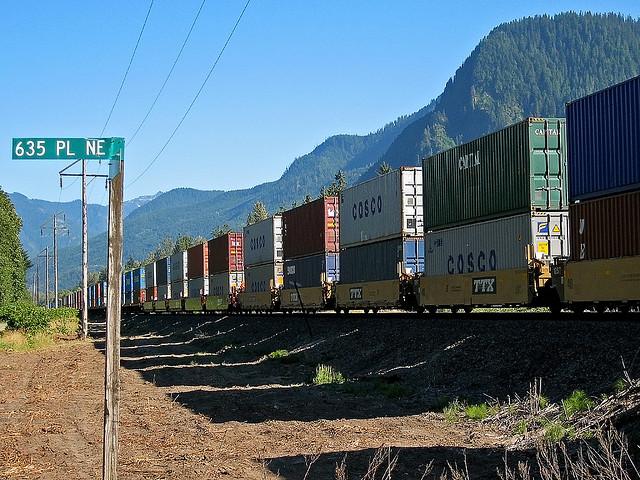What is the address on the street sign?
Keep it brief. 635 pl ne. What is word written on the side of the cargo containers?
Give a very brief answer. Costco. What type of train is this?
Quick response, please. Freight. 